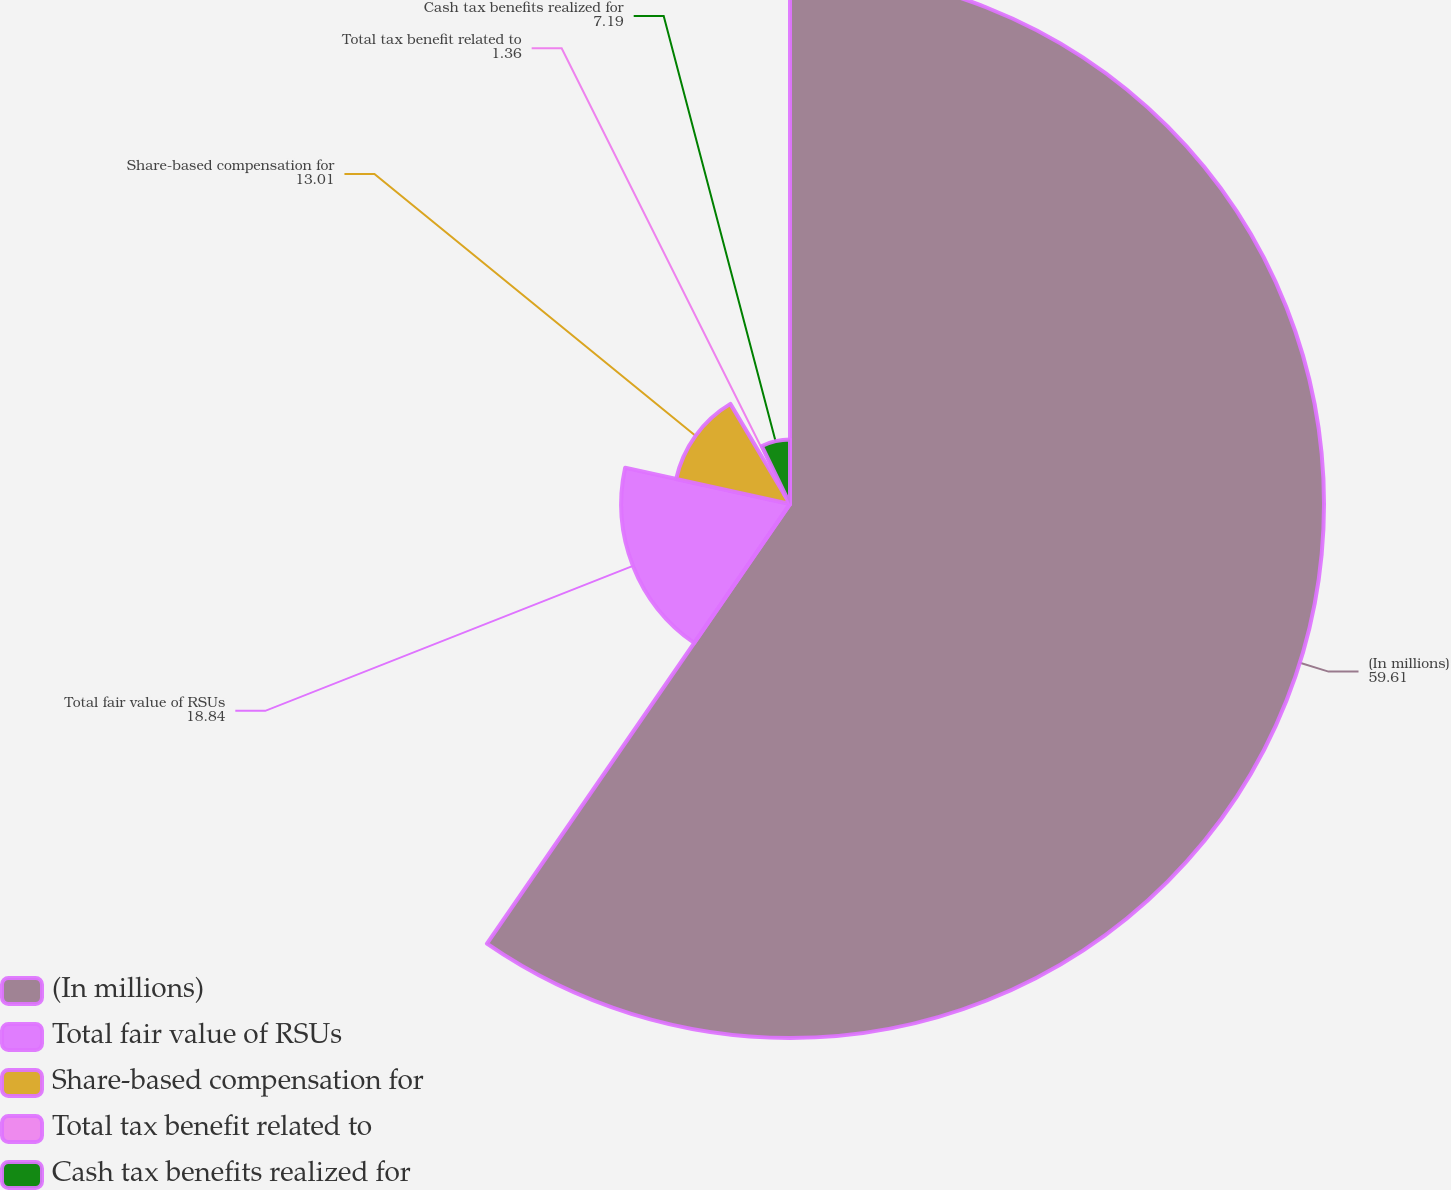<chart> <loc_0><loc_0><loc_500><loc_500><pie_chart><fcel>(In millions)<fcel>Total fair value of RSUs<fcel>Share-based compensation for<fcel>Total tax benefit related to<fcel>Cash tax benefits realized for<nl><fcel>59.61%<fcel>18.84%<fcel>13.01%<fcel>1.36%<fcel>7.19%<nl></chart> 